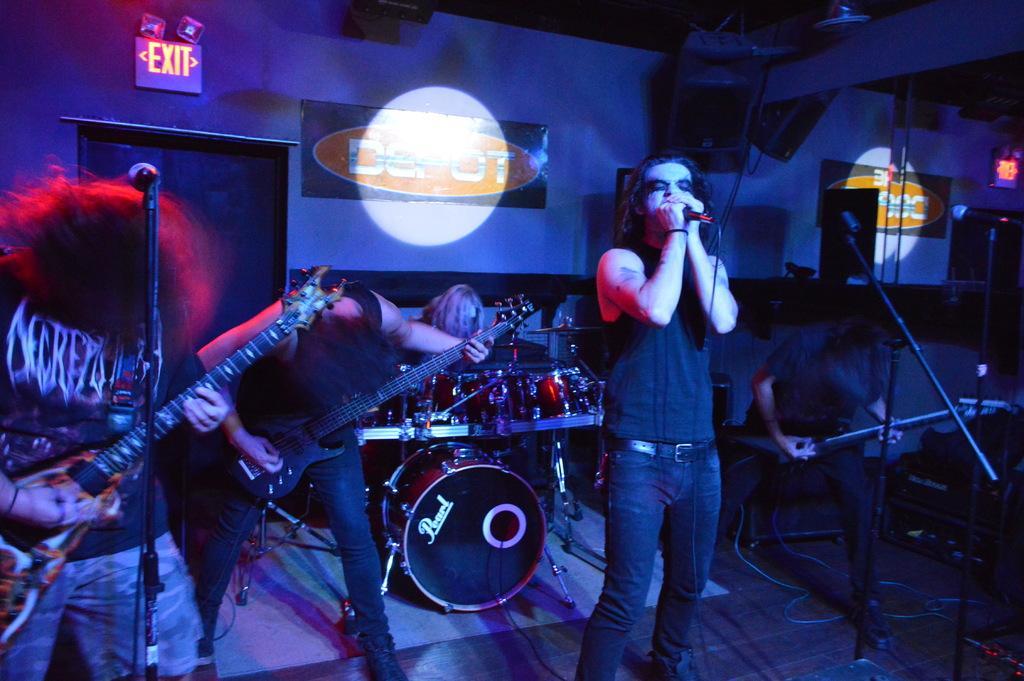Can you describe this image briefly? In this image, we can see few peoples are playing a musical instrument. And the middle, the person is holding microphone. At the background, there are so many items we can see. Here there is a exit. 